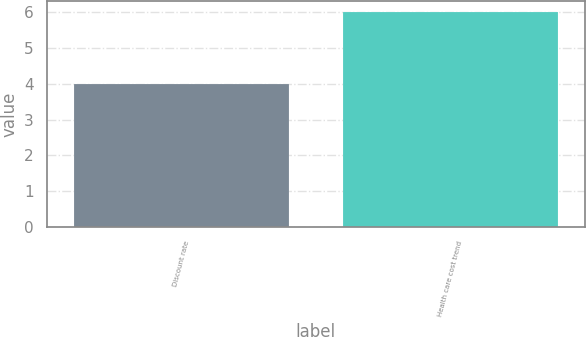<chart> <loc_0><loc_0><loc_500><loc_500><bar_chart><fcel>Discount rate<fcel>Health care cost trend<nl><fcel>4<fcel>6<nl></chart> 